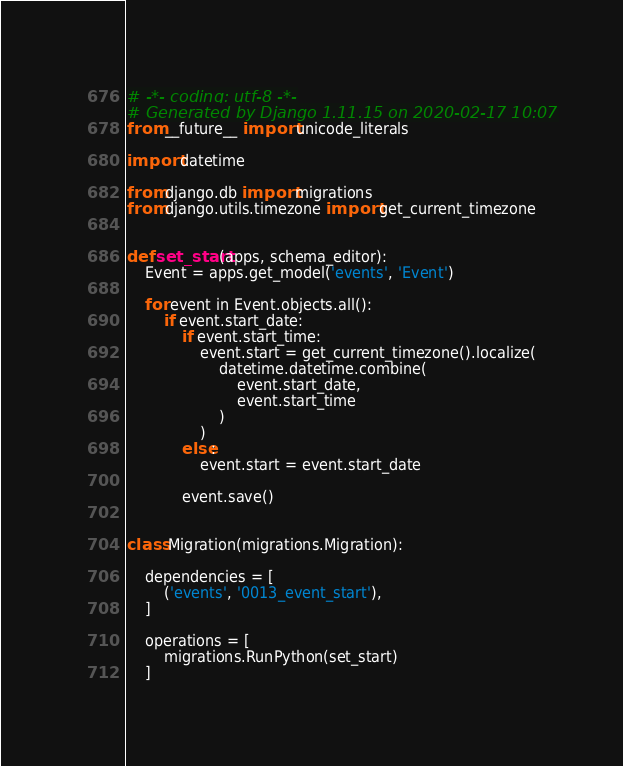Convert code to text. <code><loc_0><loc_0><loc_500><loc_500><_Python_># -*- coding: utf-8 -*-
# Generated by Django 1.11.15 on 2020-02-17 10:07
from __future__ import unicode_literals

import datetime

from django.db import migrations
from django.utils.timezone import get_current_timezone


def set_start(apps, schema_editor):
    Event = apps.get_model('events', 'Event')

    for event in Event.objects.all():
        if event.start_date:
            if event.start_time:
                event.start = get_current_timezone().localize(
                    datetime.datetime.combine(
                        event.start_date,
                        event.start_time
                    )
                )
            else:
                event.start = event.start_date

            event.save()


class Migration(migrations.Migration):

    dependencies = [
        ('events', '0013_event_start'),
    ]

    operations = [
        migrations.RunPython(set_start)
    ]
</code> 